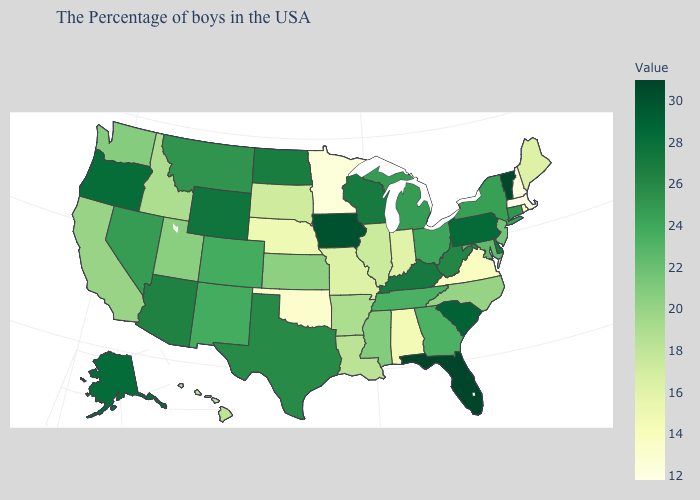Is the legend a continuous bar?
Give a very brief answer. Yes. Among the states that border California , which have the highest value?
Be succinct. Oregon. Which states hav the highest value in the West?
Short answer required. Alaska. Does Texas have the highest value in the South?
Concise answer only. No. Is the legend a continuous bar?
Keep it brief. Yes. Does Oklahoma have the lowest value in the South?
Concise answer only. Yes. 